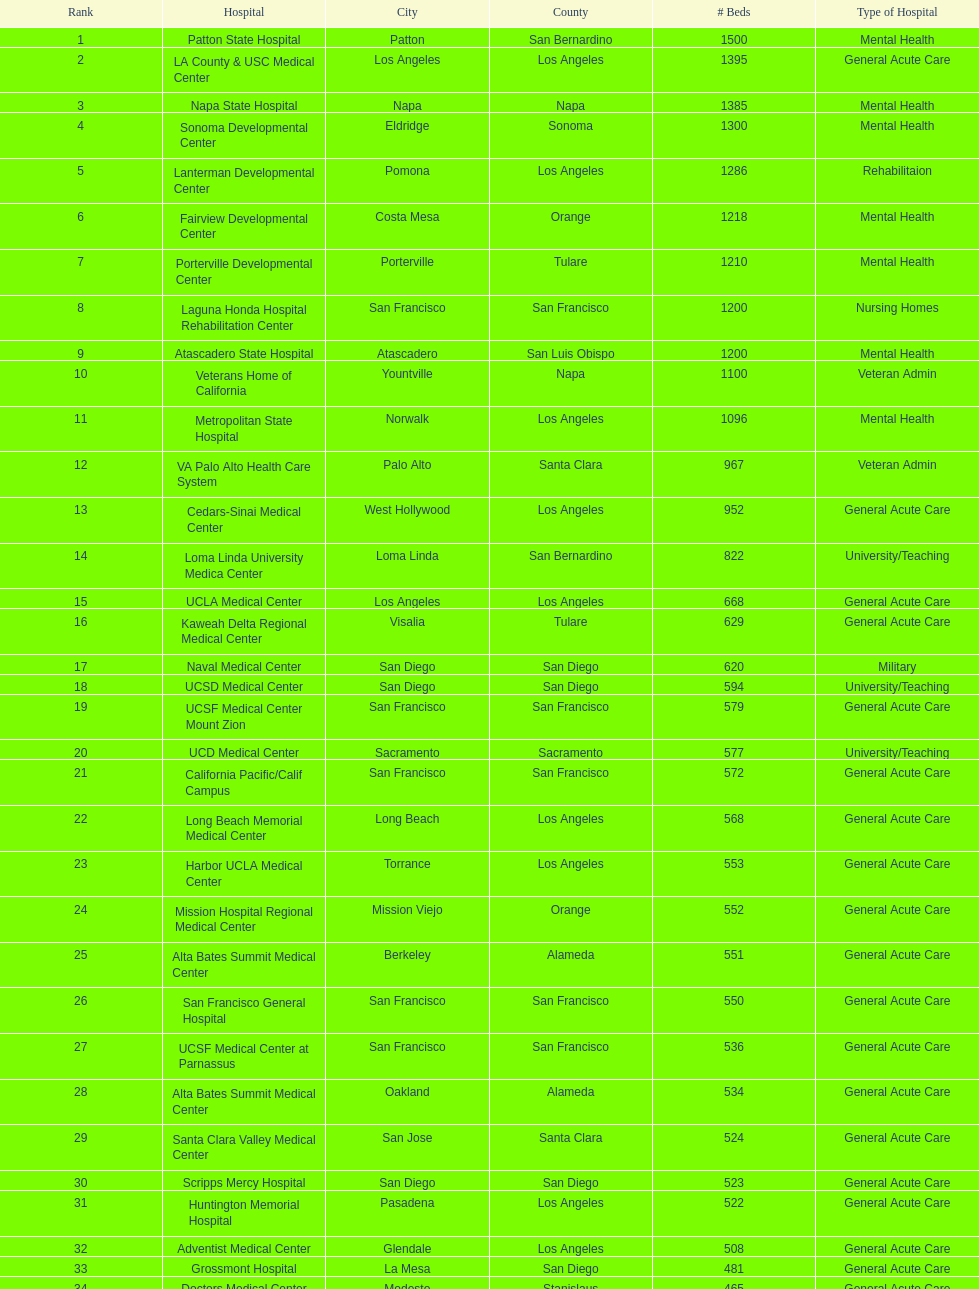What types of medical facilities are equivalent to grossmont hospital? General Acute Care. 